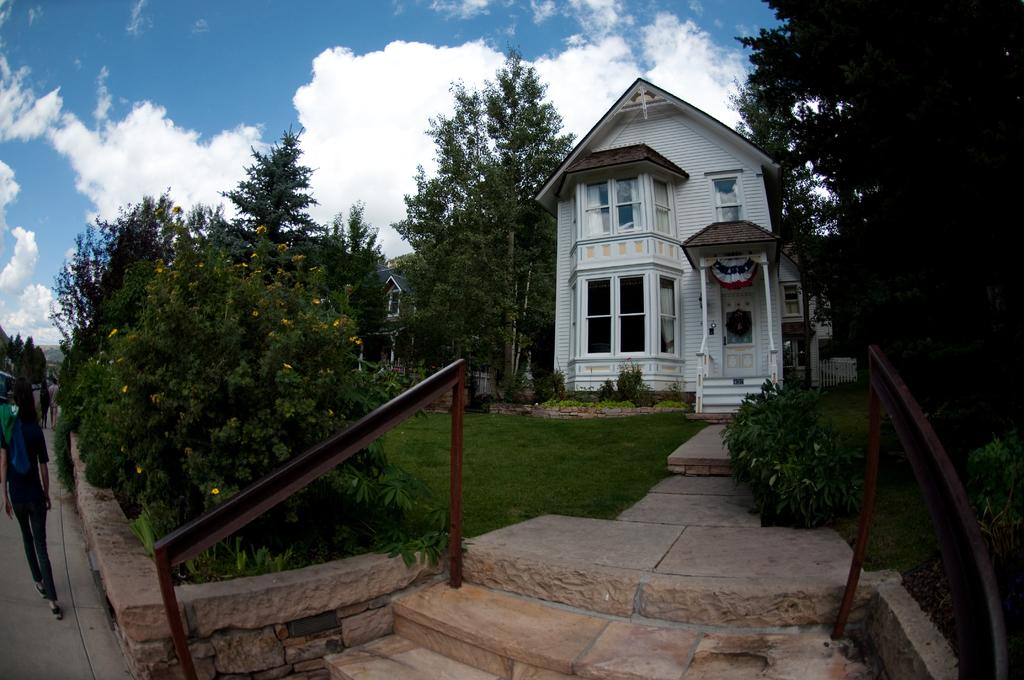What type of vegetation can be seen in the image? There is grass, plants, and trees in the image. What type of structures are present in the image? There are buildings in the image. Are there any living beings in the image? Yes, there are people in the image. What is visible in the background of the image? The sky is visible in the background of the image, and there are clouds in the sky. What type of salt can be seen on the people's faces in the image? There is no salt visible on the people's faces in the image. How does the laughter of the people in the image sound? There is no indication of laughter in the image, so it cannot be described. 